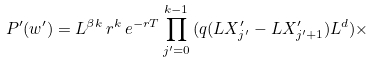Convert formula to latex. <formula><loc_0><loc_0><loc_500><loc_500>P ^ { \prime } ( w ^ { \prime } ) = L ^ { \beta k } \, r ^ { k } \, e ^ { - r T } \prod ^ { k - 1 } _ { j ^ { \prime } = 0 } \, ( q ( L X ^ { \prime } _ { j ^ { \prime } } - L X ^ { \prime } _ { j ^ { \prime } + 1 } ) L ^ { d } ) \times</formula> 